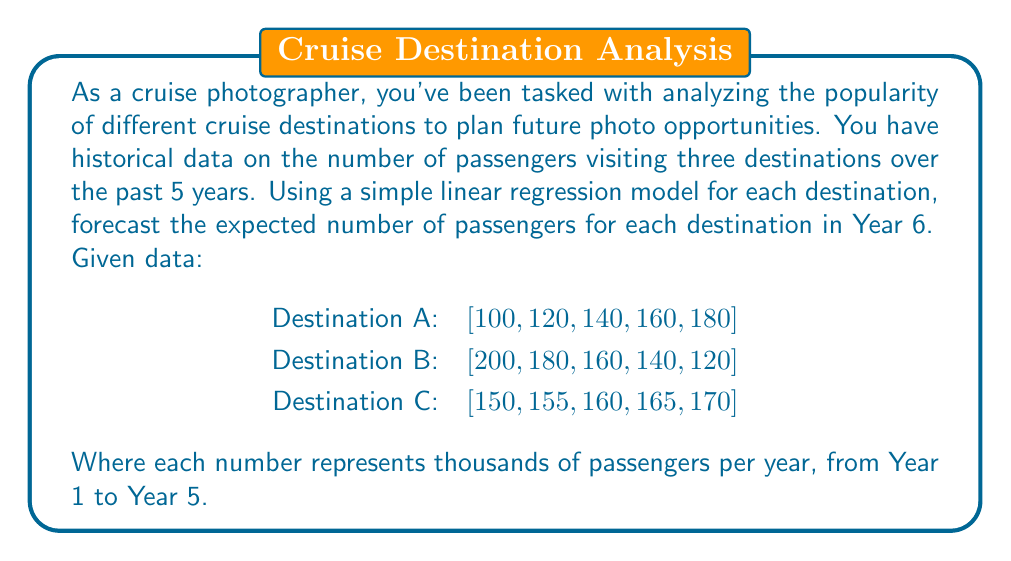Solve this math problem. To solve this problem, we'll use simple linear regression for each destination to forecast the number of passengers in Year 6. The general form of the linear regression equation is:

$$y = mx + b$$

Where $y$ is the dependent variable (number of passengers), $x$ is the independent variable (year), $m$ is the slope, and $b$ is the y-intercept.

For each destination, we'll follow these steps:
1. Calculate the slope $m$
2. Calculate the y-intercept $b$
3. Use the equation to predict Year 6

The slope $m$ can be calculated using the formula:

$$m = \frac{n\sum xy - \sum x \sum y}{n\sum x^2 - (\sum x)^2}$$

Where $n$ is the number of data points (5 in this case).

Let's calculate for each destination:

Destination A:
$\sum x = 15$, $\sum y = 700$, $\sum xy = 2300$, $\sum x^2 = 55$

$$m = \frac{5(2300) - 15(700)}{5(55) - 15^2} = 20$$

$$b = \frac{\sum y - m\sum x}{n} = \frac{700 - 20(15)}{5} = 80$$

Equation: $y = 20x + 80$
For Year 6 ($x = 6$): $y = 20(6) + 80 = 200$

Destination B:
$\sum x = 15$, $\sum y = 800$, $\sum xy = 2300$, $\sum x^2 = 55$

$$m = \frac{5(2300) - 15(800)}{5(55) - 15^2} = -20$$

$$b = \frac{\sum y - m\sum x}{n} = \frac{800 - (-20)(15)}{5} = 220$$

Equation: $y = -20x + 220$
For Year 6 ($x = 6$): $y = -20(6) + 220 = 100$

Destination C:
$\sum x = 15$, $\sum y = 800$, $\sum xy = 2475$, $\sum x^2 = 55$

$$m = \frac{5(2475) - 15(800)}{5(55) - 15^2} = 5$$

$$b = \frac{\sum y - m\sum x}{n} = \frac{800 - 5(15)}{5} = 145$$

Equation: $y = 5x + 145$
For Year 6 ($x = 6$): $y = 5(6) + 145 = 175$
Answer: The forecasted number of passengers (in thousands) for Year 6:
Destination A: 200
Destination B: 100
Destination C: 175 